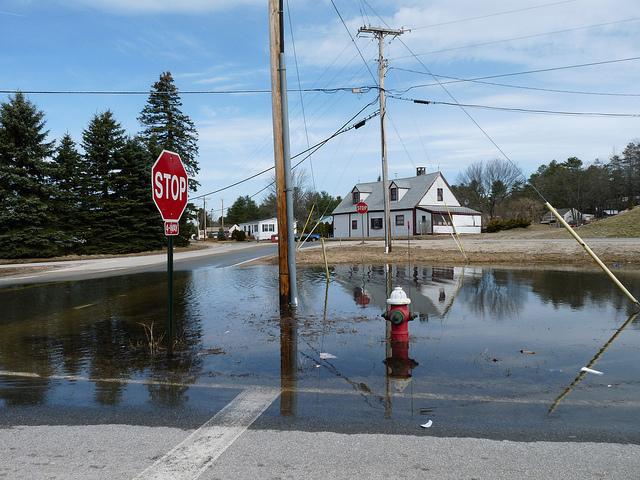How many stop signs are in the picture?
Give a very brief answer. 2. Is this area flooded?
Short answer required. Yes. Is this a four way stop?
Concise answer only. Yes. 